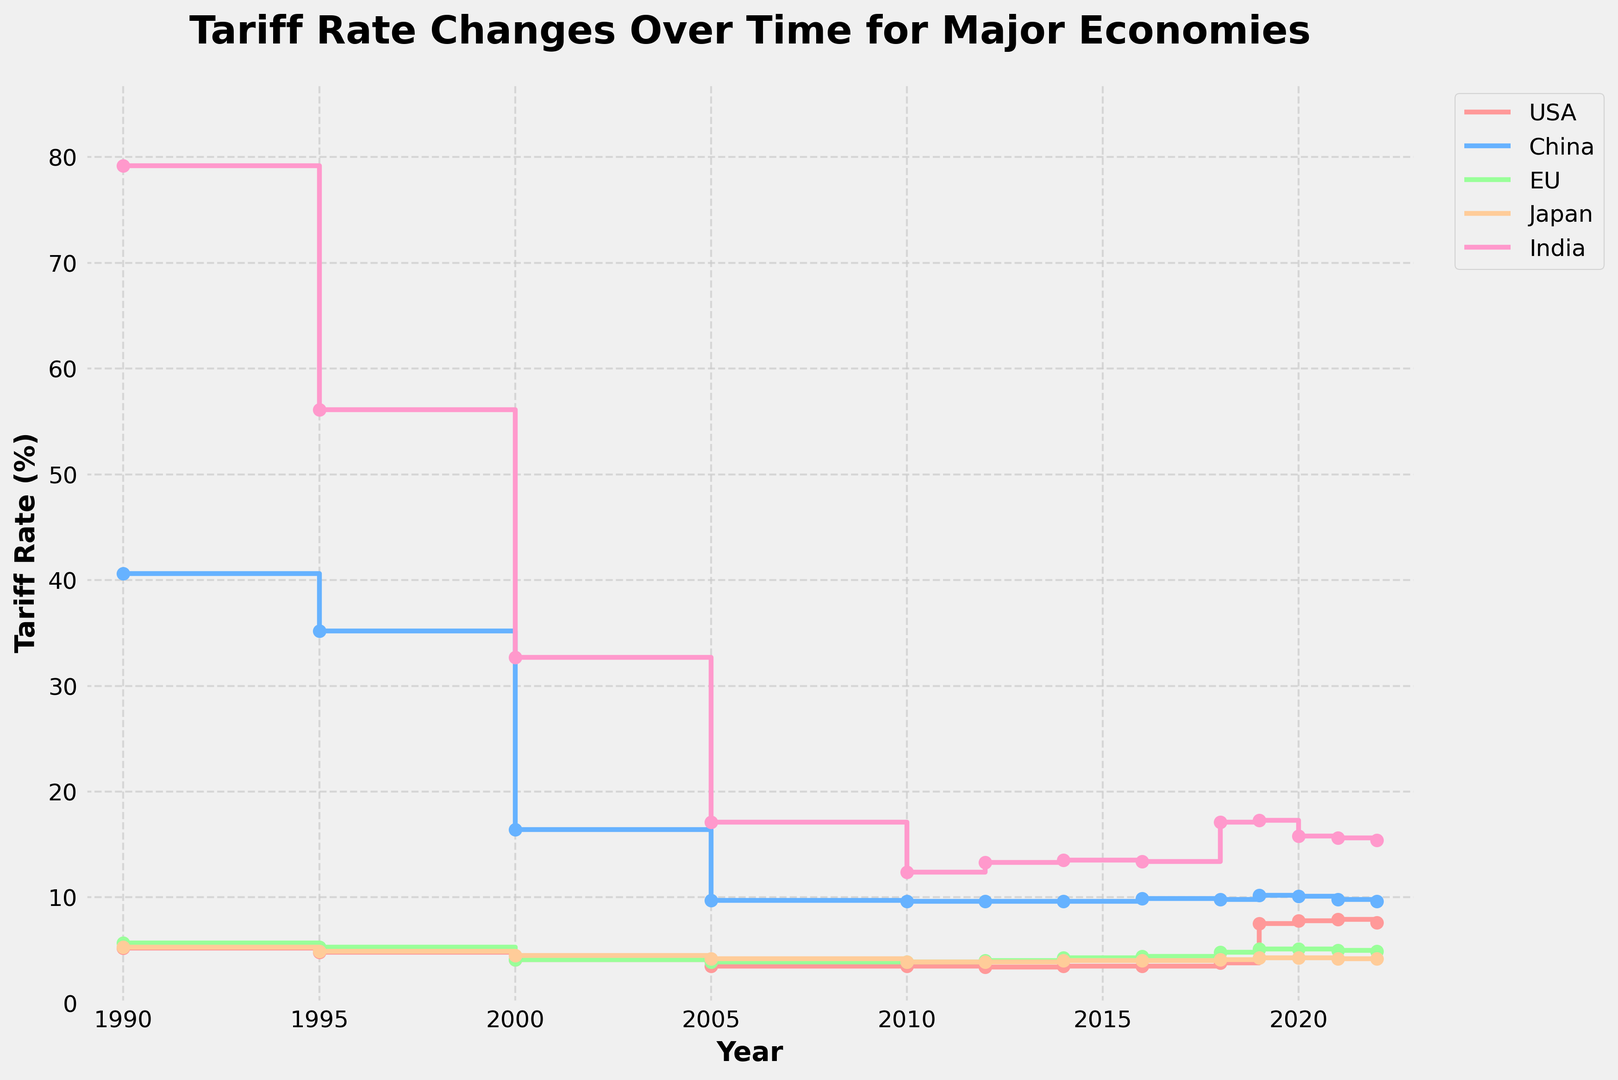Which country had the highest tariff rate in 1990? Look at the year 1990 on the x-axis and observe the corresponding points for all countries. India has the highest tariff rate shown at around 79.2%.
Answer: India Between 2000 and 2012, which country saw the largest absolute decrease in tariff rates? Examine the difference in tariff rates between 2000 and 2012 for each country. For the USA, it went from 4.1 to 3.4 (0.7 decrease); China from 16.4 to 9.6 (6.8 decrease); EU from 4.1 to 4.0 (0.1 decrease); Japan from 4.5 to 3.9 (0.6 decrease); India from 32.7 to 13.3 (19.4 decrease). India saw the largest absolute decrease.
Answer: India What is the average tariff rate for the EU from 2010 to 2022? Calculate the average by summing the EU's tariff rates from 2010 to 2022 and dividing by the number of years: (3.9 + 4.0 + 4.3 + 4.4 + 4.8 + 5.1 + 5.1 + 5.0 + 5.1 + 4.9) / 10 = 4.56.
Answer: 4.56 Compare the trends of tariff rates for the USA and China between 2016 and 2019. Who showed a more significant change and in which direction? Investigate the tariff rate changes from 2016 to 2019 for both countries. The USA went from 3.5 in 2016 to 7.5 in 2019 (increased by 4.0), and China went from 9.9 in 2016 to 10.2 in 2019 (increased by 0.3). The USA showed a more significant increase.
Answer: USA, increased Which country had the smallest variation in tariff rates over the entire period? Evaluate the range (difference between the maximum and the minimum tariff rates) for each country over the entire period. The variation for the USA is 7.9 - 3.4 = 4.5; for China, 40.6 - 9.6 = 31.0; for the EU, 5.7 - 3.9 = 1.8; for Japan, 5.3 - 3.9 = 1.4; for India, 79.2 - 12.4 = 66.8. Japan shows the smallest variation.
Answer: Japan Identify any year(s) where the tariff rate for the USA specifically increased. Observe the plot for the USA: Tariff rates increased in the years 2018, 2019, and 2020.
Answer: 2018, 2019, 2020 In which years did India have a tariff rate lower than that of China? Compare India's rates to China's for each year. India had lower rates than China in the years: 2013-2022.
Answer: 2013-2022 